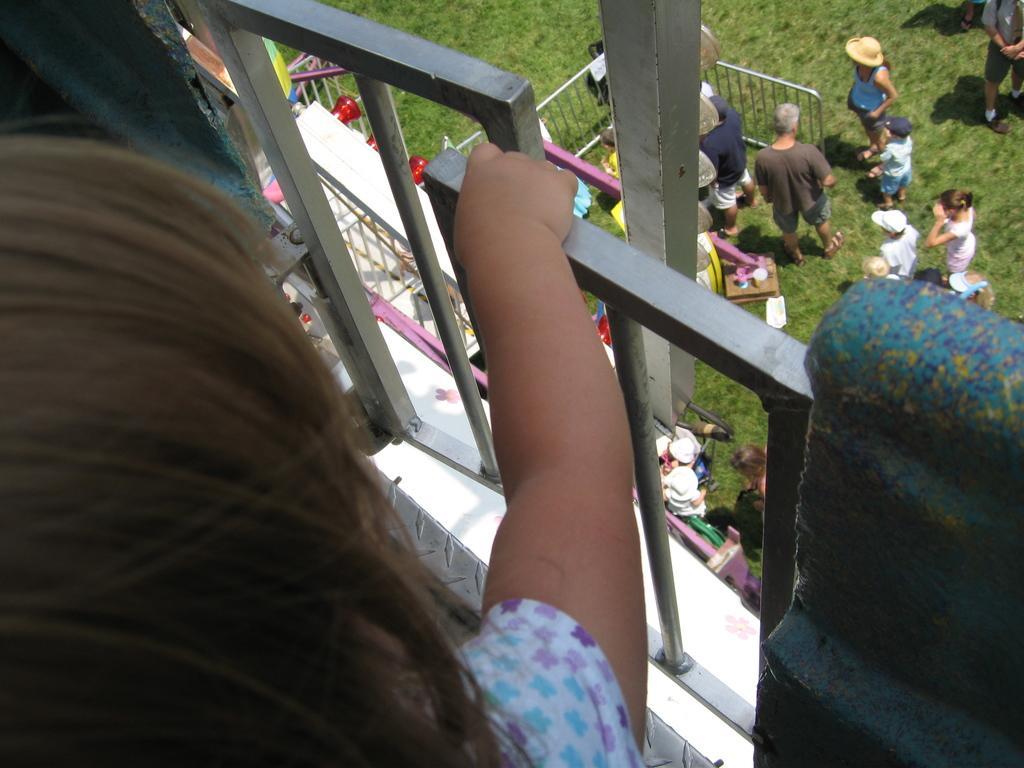Can you describe this image briefly? There is a group of persons standing on a grassy land as we can see on the right side of this image. There is one kid holding a metal object on the left side of this image. 